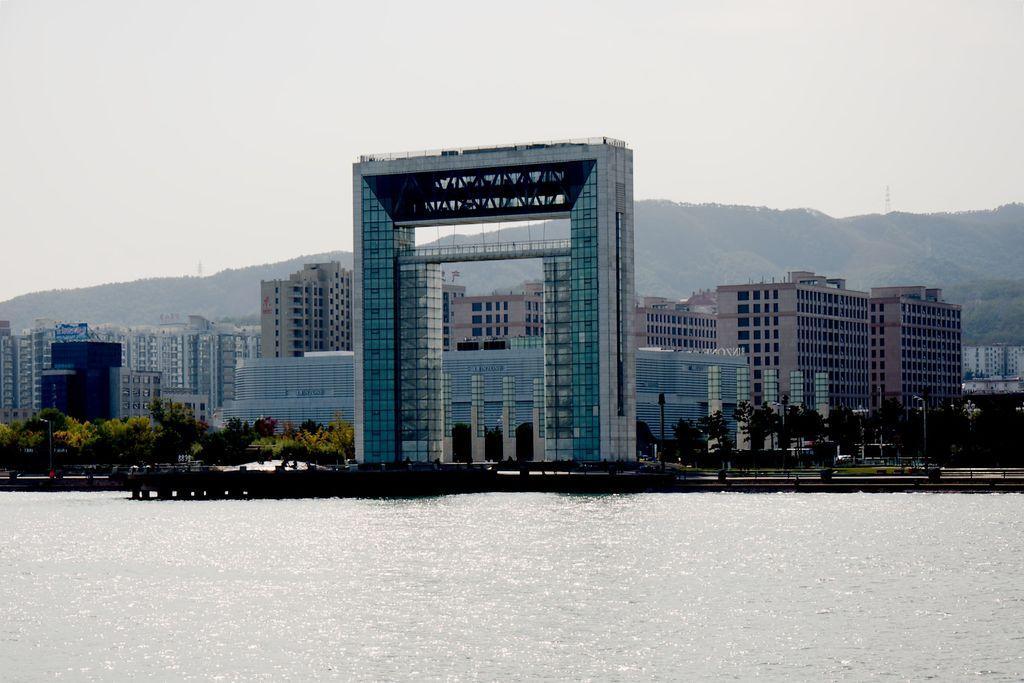In one or two sentences, can you explain what this image depicts? In the picture we can see water and far away from it, we can see a gateway with full of glasses to it and beside it, we can see some plants and behind it, we can see buildings with many floors and windows to it and behind it we can see some hills and sky. 